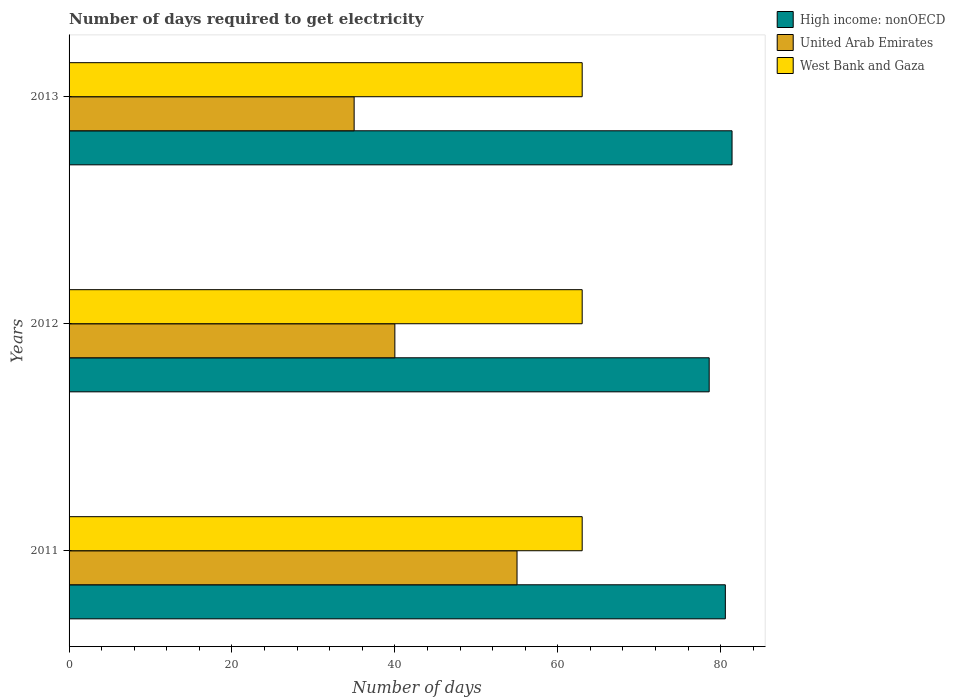How many bars are there on the 1st tick from the top?
Provide a short and direct response. 3. In how many cases, is the number of bars for a given year not equal to the number of legend labels?
Provide a short and direct response. 0. What is the number of days required to get electricity in in High income: nonOECD in 2013?
Provide a short and direct response. 81.4. Across all years, what is the maximum number of days required to get electricity in in United Arab Emirates?
Give a very brief answer. 55. Across all years, what is the minimum number of days required to get electricity in in High income: nonOECD?
Offer a terse response. 78.59. In which year was the number of days required to get electricity in in United Arab Emirates maximum?
Offer a terse response. 2011. What is the total number of days required to get electricity in in West Bank and Gaza in the graph?
Provide a short and direct response. 189. What is the difference between the number of days required to get electricity in in United Arab Emirates in 2011 and that in 2013?
Offer a terse response. 20. What is the difference between the number of days required to get electricity in in West Bank and Gaza in 2011 and the number of days required to get electricity in in United Arab Emirates in 2012?
Ensure brevity in your answer.  23. What is the average number of days required to get electricity in in High income: nonOECD per year?
Give a very brief answer. 80.19. In the year 2012, what is the difference between the number of days required to get electricity in in West Bank and Gaza and number of days required to get electricity in in United Arab Emirates?
Give a very brief answer. 23. In how many years, is the number of days required to get electricity in in United Arab Emirates greater than 76 days?
Ensure brevity in your answer.  0. Is the number of days required to get electricity in in High income: nonOECD in 2011 less than that in 2012?
Keep it short and to the point. No. Is the difference between the number of days required to get electricity in in West Bank and Gaza in 2011 and 2013 greater than the difference between the number of days required to get electricity in in United Arab Emirates in 2011 and 2013?
Your response must be concise. No. What is the difference between the highest and the second highest number of days required to get electricity in in High income: nonOECD?
Ensure brevity in your answer.  0.82. In how many years, is the number of days required to get electricity in in West Bank and Gaza greater than the average number of days required to get electricity in in West Bank and Gaza taken over all years?
Your answer should be compact. 0. What does the 1st bar from the top in 2012 represents?
Give a very brief answer. West Bank and Gaza. What does the 3rd bar from the bottom in 2012 represents?
Provide a succinct answer. West Bank and Gaza. Is it the case that in every year, the sum of the number of days required to get electricity in in High income: nonOECD and number of days required to get electricity in in West Bank and Gaza is greater than the number of days required to get electricity in in United Arab Emirates?
Provide a succinct answer. Yes. How many years are there in the graph?
Give a very brief answer. 3. What is the difference between two consecutive major ticks on the X-axis?
Give a very brief answer. 20. Where does the legend appear in the graph?
Provide a succinct answer. Top right. What is the title of the graph?
Your response must be concise. Number of days required to get electricity. Does "OECD members" appear as one of the legend labels in the graph?
Keep it short and to the point. No. What is the label or title of the X-axis?
Give a very brief answer. Number of days. What is the label or title of the Y-axis?
Give a very brief answer. Years. What is the Number of days of High income: nonOECD in 2011?
Provide a succinct answer. 80.58. What is the Number of days of High income: nonOECD in 2012?
Provide a succinct answer. 78.59. What is the Number of days of United Arab Emirates in 2012?
Ensure brevity in your answer.  40. What is the Number of days in West Bank and Gaza in 2012?
Offer a terse response. 63. What is the Number of days in High income: nonOECD in 2013?
Your answer should be compact. 81.4. What is the Number of days in West Bank and Gaza in 2013?
Provide a short and direct response. 63. Across all years, what is the maximum Number of days of High income: nonOECD?
Provide a short and direct response. 81.4. Across all years, what is the maximum Number of days in West Bank and Gaza?
Make the answer very short. 63. Across all years, what is the minimum Number of days in High income: nonOECD?
Your answer should be very brief. 78.59. What is the total Number of days in High income: nonOECD in the graph?
Ensure brevity in your answer.  240.57. What is the total Number of days in United Arab Emirates in the graph?
Offer a very short reply. 130. What is the total Number of days in West Bank and Gaza in the graph?
Your answer should be very brief. 189. What is the difference between the Number of days in High income: nonOECD in 2011 and that in 2012?
Offer a terse response. 1.98. What is the difference between the Number of days in High income: nonOECD in 2011 and that in 2013?
Keep it short and to the point. -0.82. What is the difference between the Number of days in United Arab Emirates in 2011 and that in 2013?
Ensure brevity in your answer.  20. What is the difference between the Number of days of High income: nonOECD in 2012 and that in 2013?
Keep it short and to the point. -2.81. What is the difference between the Number of days in West Bank and Gaza in 2012 and that in 2013?
Ensure brevity in your answer.  0. What is the difference between the Number of days in High income: nonOECD in 2011 and the Number of days in United Arab Emirates in 2012?
Provide a succinct answer. 40.58. What is the difference between the Number of days of High income: nonOECD in 2011 and the Number of days of West Bank and Gaza in 2012?
Provide a short and direct response. 17.58. What is the difference between the Number of days of United Arab Emirates in 2011 and the Number of days of West Bank and Gaza in 2012?
Provide a succinct answer. -8. What is the difference between the Number of days in High income: nonOECD in 2011 and the Number of days in United Arab Emirates in 2013?
Make the answer very short. 45.58. What is the difference between the Number of days of High income: nonOECD in 2011 and the Number of days of West Bank and Gaza in 2013?
Provide a short and direct response. 17.58. What is the difference between the Number of days of High income: nonOECD in 2012 and the Number of days of United Arab Emirates in 2013?
Offer a very short reply. 43.59. What is the difference between the Number of days in High income: nonOECD in 2012 and the Number of days in West Bank and Gaza in 2013?
Provide a succinct answer. 15.59. What is the average Number of days in High income: nonOECD per year?
Keep it short and to the point. 80.19. What is the average Number of days of United Arab Emirates per year?
Keep it short and to the point. 43.33. In the year 2011, what is the difference between the Number of days in High income: nonOECD and Number of days in United Arab Emirates?
Your answer should be very brief. 25.58. In the year 2011, what is the difference between the Number of days of High income: nonOECD and Number of days of West Bank and Gaza?
Offer a very short reply. 17.58. In the year 2012, what is the difference between the Number of days of High income: nonOECD and Number of days of United Arab Emirates?
Keep it short and to the point. 38.59. In the year 2012, what is the difference between the Number of days of High income: nonOECD and Number of days of West Bank and Gaza?
Give a very brief answer. 15.59. In the year 2013, what is the difference between the Number of days of High income: nonOECD and Number of days of United Arab Emirates?
Your answer should be compact. 46.4. What is the ratio of the Number of days of High income: nonOECD in 2011 to that in 2012?
Offer a very short reply. 1.03. What is the ratio of the Number of days in United Arab Emirates in 2011 to that in 2012?
Keep it short and to the point. 1.38. What is the ratio of the Number of days of United Arab Emirates in 2011 to that in 2013?
Your response must be concise. 1.57. What is the ratio of the Number of days in High income: nonOECD in 2012 to that in 2013?
Keep it short and to the point. 0.97. What is the difference between the highest and the second highest Number of days of High income: nonOECD?
Offer a terse response. 0.82. What is the difference between the highest and the lowest Number of days in High income: nonOECD?
Give a very brief answer. 2.81. 